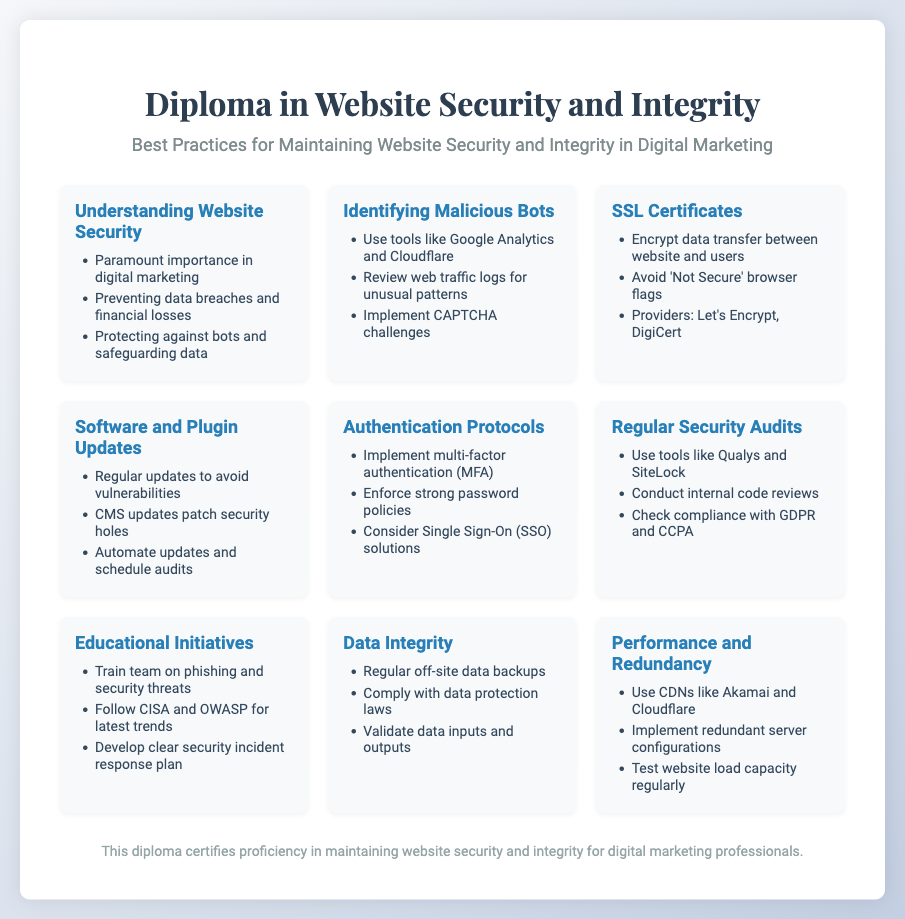what is the title of the diploma? The title is located at the top of the document in the header section.
Answer: Diploma in Website Security and Integrity how many sections are there in the content? The number of sections can be counted from the content area of the document.
Answer: 9 which tool is mentioned for identifying malicious bots? The tools listed for identifying malicious bots can be found in the corresponding section of the document.
Answer: Google Analytics what is a primary goal of maintaining website security? The goal can be found in the 'Understanding Website Security' section of the document.
Answer: Preventing data breaches which authentication method is recommended in the document? The recommended method can be found in the 'Authentication Protocols' section of the document.
Answer: Multi-factor authentication what should be regularly updated to avoid vulnerabilities? This information is found in the 'Software and Plugin Updates' section.
Answer: Software what is one purpose of having SSL certificates? The purpose can be found in the 'SSL Certificates' section of the document.
Answer: Encrypt data transfer which organization provides educational initiatives guidelines? The organization is mentioned in the 'Educational Initiatives' section of the document.
Answer: CISA how often should security audits be conducted? The frequency is not explicitly stated, but the section implies regularity.
Answer: Regularly 